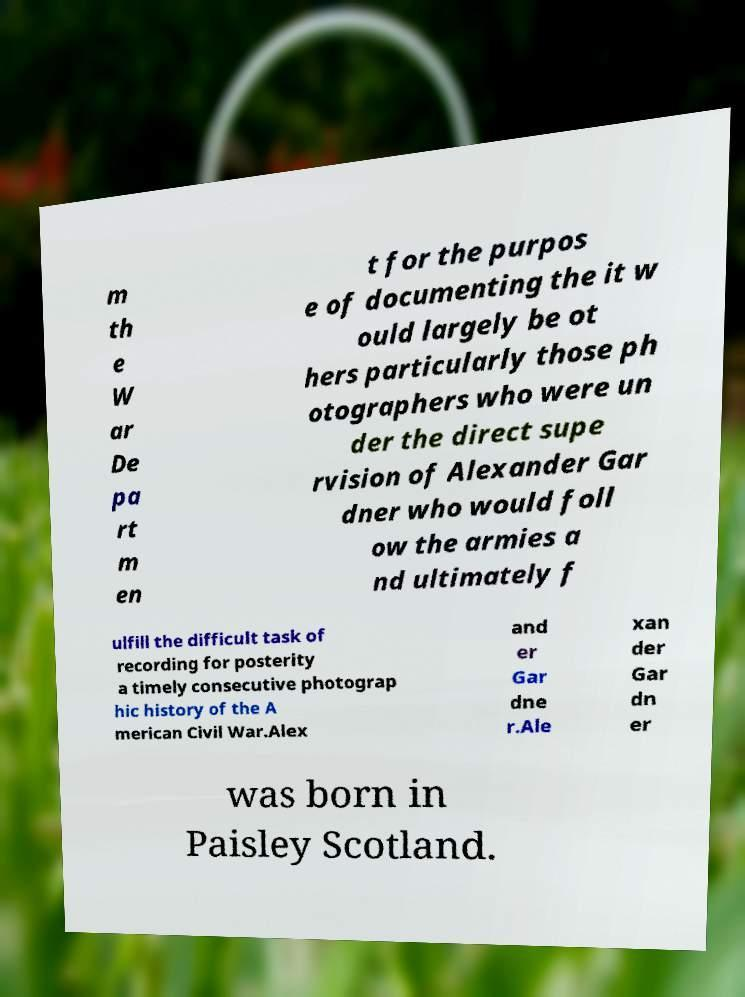Can you accurately transcribe the text from the provided image for me? m th e W ar De pa rt m en t for the purpos e of documenting the it w ould largely be ot hers particularly those ph otographers who were un der the direct supe rvision of Alexander Gar dner who would foll ow the armies a nd ultimately f ulfill the difficult task of recording for posterity a timely consecutive photograp hic history of the A merican Civil War.Alex and er Gar dne r.Ale xan der Gar dn er was born in Paisley Scotland. 